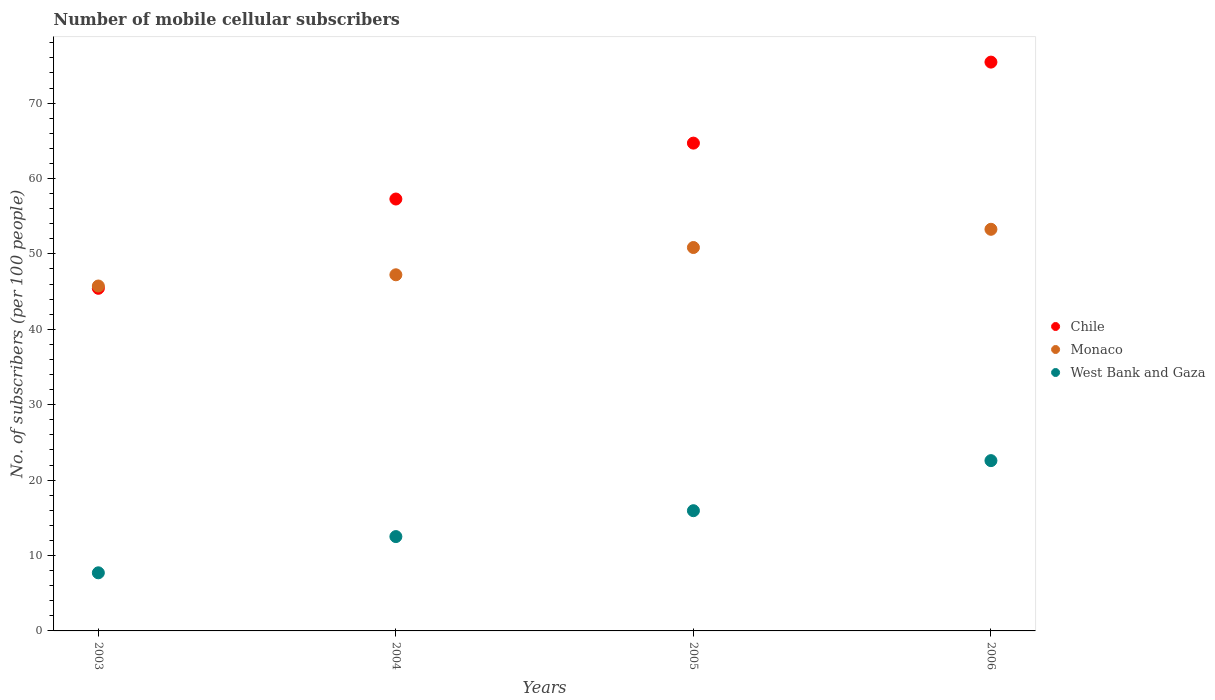Is the number of dotlines equal to the number of legend labels?
Make the answer very short. Yes. What is the number of mobile cellular subscribers in Monaco in 2005?
Your answer should be very brief. 50.85. Across all years, what is the maximum number of mobile cellular subscribers in Monaco?
Ensure brevity in your answer.  53.27. Across all years, what is the minimum number of mobile cellular subscribers in Chile?
Offer a terse response. 45.44. In which year was the number of mobile cellular subscribers in Chile maximum?
Provide a short and direct response. 2006. In which year was the number of mobile cellular subscribers in Chile minimum?
Provide a succinct answer. 2003. What is the total number of mobile cellular subscribers in Monaco in the graph?
Your response must be concise. 197.09. What is the difference between the number of mobile cellular subscribers in West Bank and Gaza in 2003 and that in 2006?
Provide a succinct answer. -14.88. What is the difference between the number of mobile cellular subscribers in Monaco in 2003 and the number of mobile cellular subscribers in Chile in 2005?
Ensure brevity in your answer.  -18.95. What is the average number of mobile cellular subscribers in Monaco per year?
Keep it short and to the point. 49.27. In the year 2005, what is the difference between the number of mobile cellular subscribers in West Bank and Gaza and number of mobile cellular subscribers in Chile?
Give a very brief answer. -48.75. What is the ratio of the number of mobile cellular subscribers in Chile in 2003 to that in 2004?
Your response must be concise. 0.79. Is the difference between the number of mobile cellular subscribers in West Bank and Gaza in 2003 and 2006 greater than the difference between the number of mobile cellular subscribers in Chile in 2003 and 2006?
Offer a very short reply. Yes. What is the difference between the highest and the second highest number of mobile cellular subscribers in Chile?
Make the answer very short. 10.74. What is the difference between the highest and the lowest number of mobile cellular subscribers in Chile?
Offer a terse response. 30. Is it the case that in every year, the sum of the number of mobile cellular subscribers in Monaco and number of mobile cellular subscribers in Chile  is greater than the number of mobile cellular subscribers in West Bank and Gaza?
Make the answer very short. Yes. Does the number of mobile cellular subscribers in Monaco monotonically increase over the years?
Your response must be concise. Yes. Is the number of mobile cellular subscribers in Monaco strictly greater than the number of mobile cellular subscribers in Chile over the years?
Make the answer very short. No. Is the number of mobile cellular subscribers in Monaco strictly less than the number of mobile cellular subscribers in Chile over the years?
Provide a short and direct response. No. How many dotlines are there?
Your answer should be compact. 3. How many years are there in the graph?
Provide a short and direct response. 4. What is the difference between two consecutive major ticks on the Y-axis?
Ensure brevity in your answer.  10. Are the values on the major ticks of Y-axis written in scientific E-notation?
Give a very brief answer. No. Does the graph contain any zero values?
Offer a very short reply. No. How many legend labels are there?
Your answer should be very brief. 3. How are the legend labels stacked?
Offer a very short reply. Vertical. What is the title of the graph?
Your answer should be compact. Number of mobile cellular subscribers. What is the label or title of the Y-axis?
Your answer should be very brief. No. of subscribers (per 100 people). What is the No. of subscribers (per 100 people) in Chile in 2003?
Offer a terse response. 45.44. What is the No. of subscribers (per 100 people) in Monaco in 2003?
Give a very brief answer. 45.74. What is the No. of subscribers (per 100 people) of West Bank and Gaza in 2003?
Keep it short and to the point. 7.71. What is the No. of subscribers (per 100 people) of Chile in 2004?
Your response must be concise. 57.28. What is the No. of subscribers (per 100 people) in Monaco in 2004?
Provide a succinct answer. 47.23. What is the No. of subscribers (per 100 people) in West Bank and Gaza in 2004?
Make the answer very short. 12.51. What is the No. of subscribers (per 100 people) in Chile in 2005?
Keep it short and to the point. 64.69. What is the No. of subscribers (per 100 people) of Monaco in 2005?
Your answer should be compact. 50.85. What is the No. of subscribers (per 100 people) of West Bank and Gaza in 2005?
Your response must be concise. 15.94. What is the No. of subscribers (per 100 people) of Chile in 2006?
Ensure brevity in your answer.  75.44. What is the No. of subscribers (per 100 people) of Monaco in 2006?
Your answer should be very brief. 53.27. What is the No. of subscribers (per 100 people) of West Bank and Gaza in 2006?
Provide a succinct answer. 22.58. Across all years, what is the maximum No. of subscribers (per 100 people) of Chile?
Provide a succinct answer. 75.44. Across all years, what is the maximum No. of subscribers (per 100 people) of Monaco?
Keep it short and to the point. 53.27. Across all years, what is the maximum No. of subscribers (per 100 people) in West Bank and Gaza?
Offer a very short reply. 22.58. Across all years, what is the minimum No. of subscribers (per 100 people) of Chile?
Keep it short and to the point. 45.44. Across all years, what is the minimum No. of subscribers (per 100 people) in Monaco?
Your answer should be very brief. 45.74. Across all years, what is the minimum No. of subscribers (per 100 people) in West Bank and Gaza?
Provide a short and direct response. 7.71. What is the total No. of subscribers (per 100 people) of Chile in the graph?
Your answer should be compact. 242.85. What is the total No. of subscribers (per 100 people) in Monaco in the graph?
Ensure brevity in your answer.  197.09. What is the total No. of subscribers (per 100 people) of West Bank and Gaza in the graph?
Your answer should be very brief. 58.75. What is the difference between the No. of subscribers (per 100 people) of Chile in 2003 and that in 2004?
Make the answer very short. -11.84. What is the difference between the No. of subscribers (per 100 people) in Monaco in 2003 and that in 2004?
Give a very brief answer. -1.49. What is the difference between the No. of subscribers (per 100 people) of West Bank and Gaza in 2003 and that in 2004?
Offer a very short reply. -4.8. What is the difference between the No. of subscribers (per 100 people) in Chile in 2003 and that in 2005?
Provide a short and direct response. -19.26. What is the difference between the No. of subscribers (per 100 people) of Monaco in 2003 and that in 2005?
Offer a very short reply. -5.1. What is the difference between the No. of subscribers (per 100 people) in West Bank and Gaza in 2003 and that in 2005?
Offer a very short reply. -8.24. What is the difference between the No. of subscribers (per 100 people) of Chile in 2003 and that in 2006?
Your response must be concise. -30. What is the difference between the No. of subscribers (per 100 people) of Monaco in 2003 and that in 2006?
Your response must be concise. -7.52. What is the difference between the No. of subscribers (per 100 people) in West Bank and Gaza in 2003 and that in 2006?
Your answer should be very brief. -14.88. What is the difference between the No. of subscribers (per 100 people) in Chile in 2004 and that in 2005?
Provide a succinct answer. -7.41. What is the difference between the No. of subscribers (per 100 people) of Monaco in 2004 and that in 2005?
Make the answer very short. -3.62. What is the difference between the No. of subscribers (per 100 people) of West Bank and Gaza in 2004 and that in 2005?
Your response must be concise. -3.43. What is the difference between the No. of subscribers (per 100 people) in Chile in 2004 and that in 2006?
Offer a terse response. -18.16. What is the difference between the No. of subscribers (per 100 people) of Monaco in 2004 and that in 2006?
Offer a terse response. -6.03. What is the difference between the No. of subscribers (per 100 people) of West Bank and Gaza in 2004 and that in 2006?
Give a very brief answer. -10.07. What is the difference between the No. of subscribers (per 100 people) of Chile in 2005 and that in 2006?
Keep it short and to the point. -10.74. What is the difference between the No. of subscribers (per 100 people) in Monaco in 2005 and that in 2006?
Offer a terse response. -2.42. What is the difference between the No. of subscribers (per 100 people) in West Bank and Gaza in 2005 and that in 2006?
Give a very brief answer. -6.64. What is the difference between the No. of subscribers (per 100 people) in Chile in 2003 and the No. of subscribers (per 100 people) in Monaco in 2004?
Provide a succinct answer. -1.79. What is the difference between the No. of subscribers (per 100 people) of Chile in 2003 and the No. of subscribers (per 100 people) of West Bank and Gaza in 2004?
Provide a short and direct response. 32.93. What is the difference between the No. of subscribers (per 100 people) of Monaco in 2003 and the No. of subscribers (per 100 people) of West Bank and Gaza in 2004?
Offer a terse response. 33.23. What is the difference between the No. of subscribers (per 100 people) in Chile in 2003 and the No. of subscribers (per 100 people) in Monaco in 2005?
Provide a short and direct response. -5.41. What is the difference between the No. of subscribers (per 100 people) of Chile in 2003 and the No. of subscribers (per 100 people) of West Bank and Gaza in 2005?
Your answer should be compact. 29.5. What is the difference between the No. of subscribers (per 100 people) of Monaco in 2003 and the No. of subscribers (per 100 people) of West Bank and Gaza in 2005?
Provide a succinct answer. 29.8. What is the difference between the No. of subscribers (per 100 people) in Chile in 2003 and the No. of subscribers (per 100 people) in Monaco in 2006?
Provide a succinct answer. -7.83. What is the difference between the No. of subscribers (per 100 people) in Chile in 2003 and the No. of subscribers (per 100 people) in West Bank and Gaza in 2006?
Make the answer very short. 22.85. What is the difference between the No. of subscribers (per 100 people) of Monaco in 2003 and the No. of subscribers (per 100 people) of West Bank and Gaza in 2006?
Give a very brief answer. 23.16. What is the difference between the No. of subscribers (per 100 people) of Chile in 2004 and the No. of subscribers (per 100 people) of Monaco in 2005?
Offer a very short reply. 6.43. What is the difference between the No. of subscribers (per 100 people) in Chile in 2004 and the No. of subscribers (per 100 people) in West Bank and Gaza in 2005?
Your answer should be compact. 41.34. What is the difference between the No. of subscribers (per 100 people) in Monaco in 2004 and the No. of subscribers (per 100 people) in West Bank and Gaza in 2005?
Make the answer very short. 31.29. What is the difference between the No. of subscribers (per 100 people) in Chile in 2004 and the No. of subscribers (per 100 people) in Monaco in 2006?
Offer a very short reply. 4.02. What is the difference between the No. of subscribers (per 100 people) of Chile in 2004 and the No. of subscribers (per 100 people) of West Bank and Gaza in 2006?
Ensure brevity in your answer.  34.7. What is the difference between the No. of subscribers (per 100 people) of Monaco in 2004 and the No. of subscribers (per 100 people) of West Bank and Gaza in 2006?
Keep it short and to the point. 24.65. What is the difference between the No. of subscribers (per 100 people) in Chile in 2005 and the No. of subscribers (per 100 people) in Monaco in 2006?
Provide a short and direct response. 11.43. What is the difference between the No. of subscribers (per 100 people) in Chile in 2005 and the No. of subscribers (per 100 people) in West Bank and Gaza in 2006?
Your answer should be very brief. 42.11. What is the difference between the No. of subscribers (per 100 people) of Monaco in 2005 and the No. of subscribers (per 100 people) of West Bank and Gaza in 2006?
Make the answer very short. 28.26. What is the average No. of subscribers (per 100 people) in Chile per year?
Give a very brief answer. 60.71. What is the average No. of subscribers (per 100 people) of Monaco per year?
Provide a short and direct response. 49.27. What is the average No. of subscribers (per 100 people) of West Bank and Gaza per year?
Your answer should be very brief. 14.69. In the year 2003, what is the difference between the No. of subscribers (per 100 people) in Chile and No. of subscribers (per 100 people) in Monaco?
Your response must be concise. -0.31. In the year 2003, what is the difference between the No. of subscribers (per 100 people) of Chile and No. of subscribers (per 100 people) of West Bank and Gaza?
Your response must be concise. 37.73. In the year 2003, what is the difference between the No. of subscribers (per 100 people) of Monaco and No. of subscribers (per 100 people) of West Bank and Gaza?
Provide a succinct answer. 38.04. In the year 2004, what is the difference between the No. of subscribers (per 100 people) in Chile and No. of subscribers (per 100 people) in Monaco?
Keep it short and to the point. 10.05. In the year 2004, what is the difference between the No. of subscribers (per 100 people) of Chile and No. of subscribers (per 100 people) of West Bank and Gaza?
Your response must be concise. 44.77. In the year 2004, what is the difference between the No. of subscribers (per 100 people) of Monaco and No. of subscribers (per 100 people) of West Bank and Gaza?
Give a very brief answer. 34.72. In the year 2005, what is the difference between the No. of subscribers (per 100 people) in Chile and No. of subscribers (per 100 people) in Monaco?
Make the answer very short. 13.85. In the year 2005, what is the difference between the No. of subscribers (per 100 people) of Chile and No. of subscribers (per 100 people) of West Bank and Gaza?
Provide a succinct answer. 48.75. In the year 2005, what is the difference between the No. of subscribers (per 100 people) in Monaco and No. of subscribers (per 100 people) in West Bank and Gaza?
Your answer should be compact. 34.9. In the year 2006, what is the difference between the No. of subscribers (per 100 people) of Chile and No. of subscribers (per 100 people) of Monaco?
Your response must be concise. 22.17. In the year 2006, what is the difference between the No. of subscribers (per 100 people) in Chile and No. of subscribers (per 100 people) in West Bank and Gaza?
Provide a short and direct response. 52.85. In the year 2006, what is the difference between the No. of subscribers (per 100 people) of Monaco and No. of subscribers (per 100 people) of West Bank and Gaza?
Your response must be concise. 30.68. What is the ratio of the No. of subscribers (per 100 people) of Chile in 2003 to that in 2004?
Provide a succinct answer. 0.79. What is the ratio of the No. of subscribers (per 100 people) of Monaco in 2003 to that in 2004?
Offer a very short reply. 0.97. What is the ratio of the No. of subscribers (per 100 people) in West Bank and Gaza in 2003 to that in 2004?
Provide a short and direct response. 0.62. What is the ratio of the No. of subscribers (per 100 people) in Chile in 2003 to that in 2005?
Offer a terse response. 0.7. What is the ratio of the No. of subscribers (per 100 people) in Monaco in 2003 to that in 2005?
Ensure brevity in your answer.  0.9. What is the ratio of the No. of subscribers (per 100 people) of West Bank and Gaza in 2003 to that in 2005?
Provide a succinct answer. 0.48. What is the ratio of the No. of subscribers (per 100 people) in Chile in 2003 to that in 2006?
Offer a very short reply. 0.6. What is the ratio of the No. of subscribers (per 100 people) in Monaco in 2003 to that in 2006?
Offer a very short reply. 0.86. What is the ratio of the No. of subscribers (per 100 people) in West Bank and Gaza in 2003 to that in 2006?
Offer a very short reply. 0.34. What is the ratio of the No. of subscribers (per 100 people) of Chile in 2004 to that in 2005?
Your answer should be very brief. 0.89. What is the ratio of the No. of subscribers (per 100 people) in Monaco in 2004 to that in 2005?
Make the answer very short. 0.93. What is the ratio of the No. of subscribers (per 100 people) of West Bank and Gaza in 2004 to that in 2005?
Your response must be concise. 0.78. What is the ratio of the No. of subscribers (per 100 people) in Chile in 2004 to that in 2006?
Keep it short and to the point. 0.76. What is the ratio of the No. of subscribers (per 100 people) in Monaco in 2004 to that in 2006?
Provide a succinct answer. 0.89. What is the ratio of the No. of subscribers (per 100 people) of West Bank and Gaza in 2004 to that in 2006?
Make the answer very short. 0.55. What is the ratio of the No. of subscribers (per 100 people) of Chile in 2005 to that in 2006?
Give a very brief answer. 0.86. What is the ratio of the No. of subscribers (per 100 people) of Monaco in 2005 to that in 2006?
Your response must be concise. 0.95. What is the ratio of the No. of subscribers (per 100 people) of West Bank and Gaza in 2005 to that in 2006?
Your answer should be very brief. 0.71. What is the difference between the highest and the second highest No. of subscribers (per 100 people) in Chile?
Your answer should be compact. 10.74. What is the difference between the highest and the second highest No. of subscribers (per 100 people) in Monaco?
Make the answer very short. 2.42. What is the difference between the highest and the second highest No. of subscribers (per 100 people) in West Bank and Gaza?
Provide a short and direct response. 6.64. What is the difference between the highest and the lowest No. of subscribers (per 100 people) in Chile?
Ensure brevity in your answer.  30. What is the difference between the highest and the lowest No. of subscribers (per 100 people) in Monaco?
Ensure brevity in your answer.  7.52. What is the difference between the highest and the lowest No. of subscribers (per 100 people) of West Bank and Gaza?
Keep it short and to the point. 14.88. 